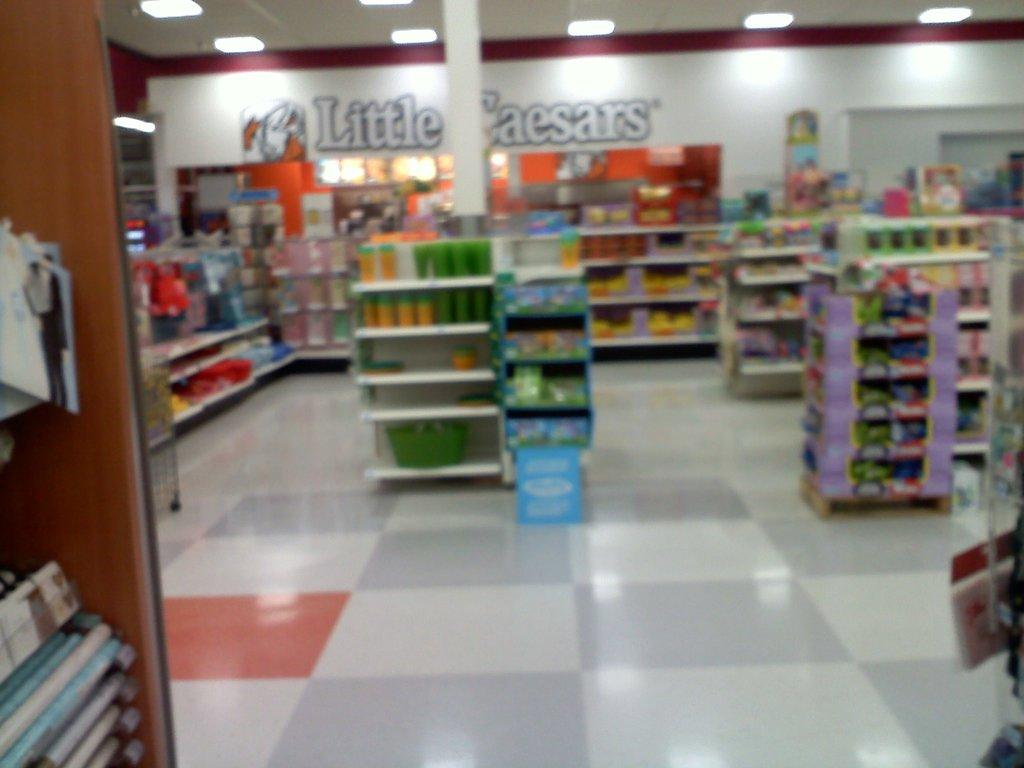<image>
Provide a brief description of the given image. A convenience store with a candy section and a sign that says Little Caesars. 